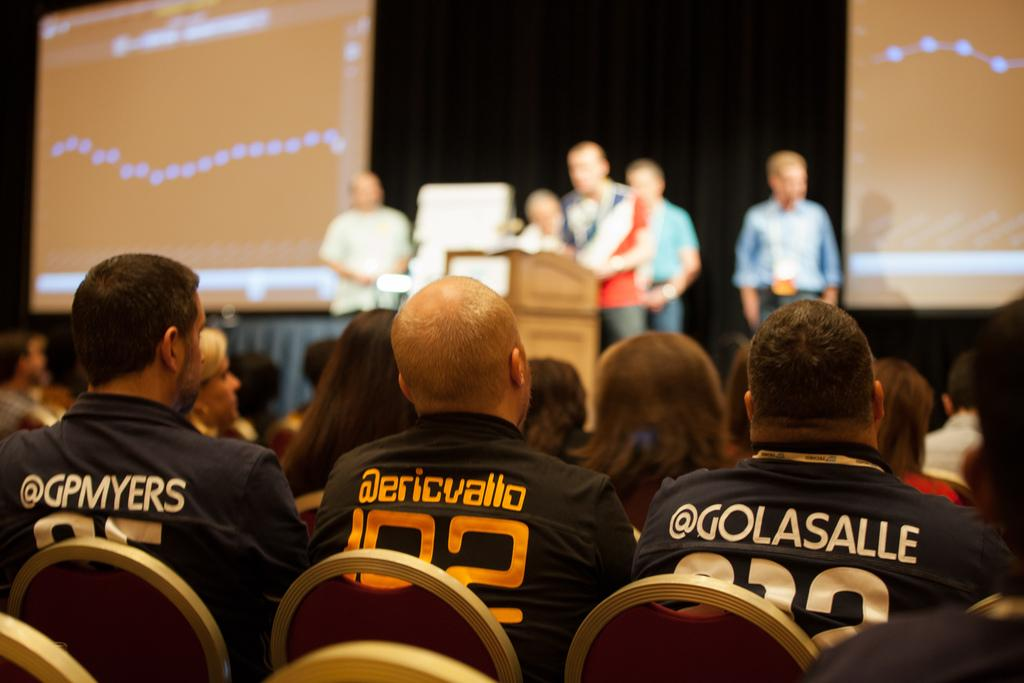What are the people in the image doing? The people in the image are sitting in chairs and standing in front of the seated people. What can be seen on either side of the standing people? There are projected images on either side of the standing people in the image. Can you describe the playground equipment visible in the image? There is no playground equipment visible in the image; it features people sitting and standing with projected images on either side. What is the taste of the image? The image does not have a taste, as it is a visual representation and not a consumable item. 